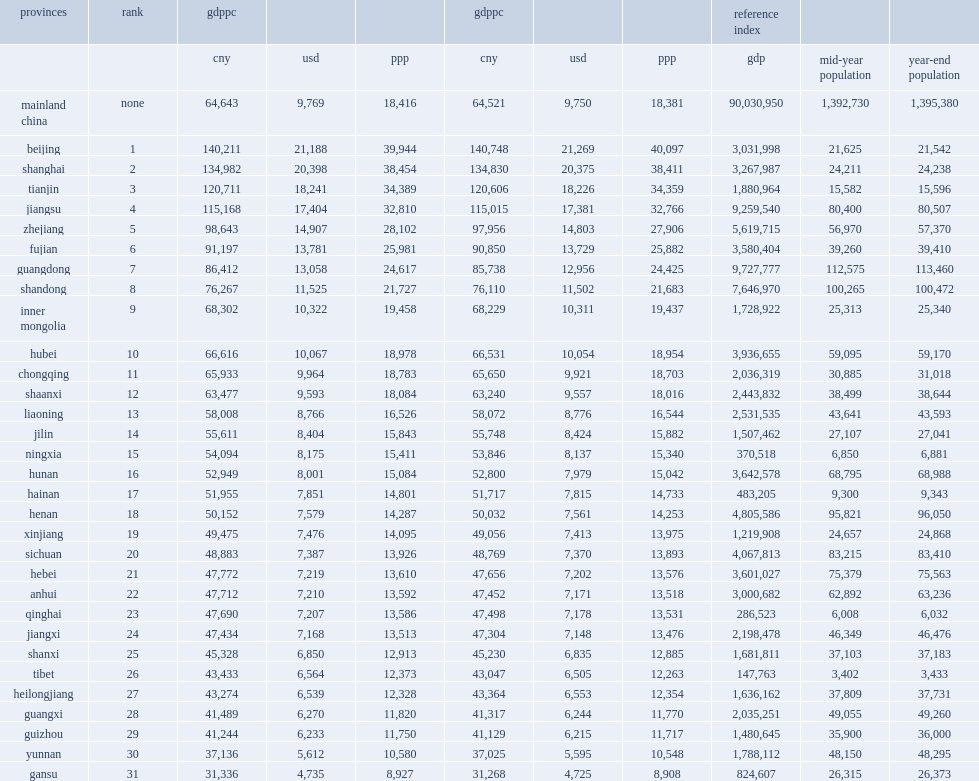What s the zhejiang's gdp per capita in dollar? 14907.0. Parse the table in full. {'header': ['provinces', 'rank', 'gdppc', '', '', 'gdppc', '', '', 'reference index', '', ''], 'rows': [['', '', 'cny', 'usd', 'ppp', 'cny', 'usd', 'ppp', 'gdp', 'mid-year population', 'year-end population'], ['mainland china', 'none', '64,643', '9,769', '18,416', '64,521', '9,750', '18,381', '90,030,950', '1,392,730', '1,395,380'], ['beijing', '1', '140,211', '21,188', '39,944', '140,748', '21,269', '40,097', '3,031,998', '21,625', '21,542'], ['shanghai', '2', '134,982', '20,398', '38,454', '134,830', '20,375', '38,411', '3,267,987', '24,211', '24,238'], ['tianjin', '3', '120,711', '18,241', '34,389', '120,606', '18,226', '34,359', '1,880,964', '15,582', '15,596'], ['jiangsu', '4', '115,168', '17,404', '32,810', '115,015', '17,381', '32,766', '9,259,540', '80,400', '80,507'], ['zhejiang', '5', '98,643', '14,907', '28,102', '97,956', '14,803', '27,906', '5,619,715', '56,970', '57,370'], ['fujian', '6', '91,197', '13,781', '25,981', '90,850', '13,729', '25,882', '3,580,404', '39,260', '39,410'], ['guangdong', '7', '86,412', '13,058', '24,617', '85,738', '12,956', '24,425', '9,727,777', '112,575', '113,460'], ['shandong', '8', '76,267', '11,525', '21,727', '76,110', '11,502', '21,683', '7,646,970', '100,265', '100,472'], ['inner mongolia', '9', '68,302', '10,322', '19,458', '68,229', '10,311', '19,437', '1,728,922', '25,313', '25,340'], ['hubei', '10', '66,616', '10,067', '18,978', '66,531', '10,054', '18,954', '3,936,655', '59,095', '59,170'], ['chongqing', '11', '65,933', '9,964', '18,783', '65,650', '9,921', '18,703', '2,036,319', '30,885', '31,018'], ['shaanxi', '12', '63,477', '9,593', '18,084', '63,240', '9,557', '18,016', '2,443,832', '38,499', '38,644'], ['liaoning', '13', '58,008', '8,766', '16,526', '58,072', '8,776', '16,544', '2,531,535', '43,641', '43,593'], ['jilin', '14', '55,611', '8,404', '15,843', '55,748', '8,424', '15,882', '1,507,462', '27,107', '27,041'], ['ningxia', '15', '54,094', '8,175', '15,411', '53,846', '8,137', '15,340', '370,518', '6,850', '6,881'], ['hunan', '16', '52,949', '8,001', '15,084', '52,800', '7,979', '15,042', '3,642,578', '68,795', '68,988'], ['hainan', '17', '51,955', '7,851', '14,801', '51,717', '7,815', '14,733', '483,205', '9,300', '9,343'], ['henan', '18', '50,152', '7,579', '14,287', '50,032', '7,561', '14,253', '4,805,586', '95,821', '96,050'], ['xinjiang', '19', '49,475', '7,476', '14,095', '49,056', '7,413', '13,975', '1,219,908', '24,657', '24,868'], ['sichuan', '20', '48,883', '7,387', '13,926', '48,769', '7,370', '13,893', '4,067,813', '83,215', '83,410'], ['hebei', '21', '47,772', '7,219', '13,610', '47,656', '7,202', '13,576', '3,601,027', '75,379', '75,563'], ['anhui', '22', '47,712', '7,210', '13,592', '47,452', '7,171', '13,518', '3,000,682', '62,892', '63,236'], ['qinghai', '23', '47,690', '7,207', '13,586', '47,498', '7,178', '13,531', '286,523', '6,008', '6,032'], ['jiangxi', '24', '47,434', '7,168', '13,513', '47,304', '7,148', '13,476', '2,198,478', '46,349', '46,476'], ['shanxi', '25', '45,328', '6,850', '12,913', '45,230', '6,835', '12,885', '1,681,811', '37,103', '37,183'], ['tibet', '26', '43,433', '6,564', '12,373', '43,047', '6,505', '12,263', '147,763', '3,402', '3,433'], ['heilongjiang', '27', '43,274', '6,539', '12,328', '43,364', '6,553', '12,354', '1,636,162', '37,809', '37,731'], ['guangxi', '28', '41,489', '6,270', '11,820', '41,317', '6,244', '11,770', '2,035,251', '49,055', '49,260'], ['guizhou', '29', '41,244', '6,233', '11,750', '41,129', '6,215', '11,717', '1,480,645', '35,900', '36,000'], ['yunnan', '30', '37,136', '5,612', '10,580', '37,025', '5,595', '10,548', '1,788,112', '48,150', '48,295'], ['gansu', '31', '31,336', '4,735', '8,927', '31,268', '4,725', '8,908', '824,607', '26,315', '26,373']]} 